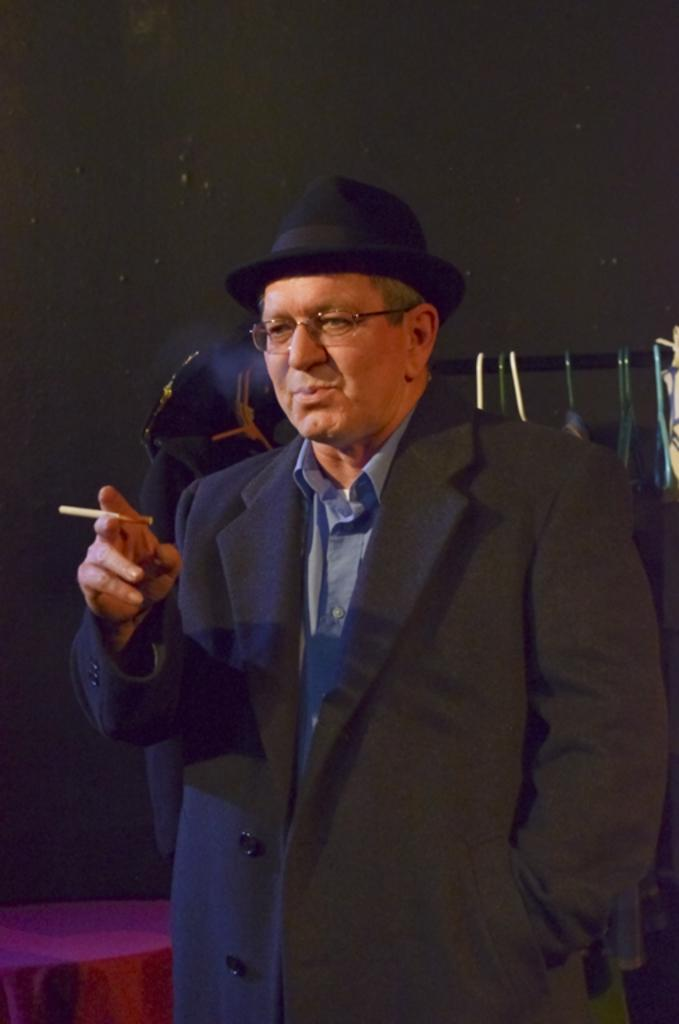Who is present in the image? There is a man in the image. What is the man wearing? The man is wearing a suit. What accessory is the man wearing on his face? The man has spectacles. What can be seen in the background of the image? There is a wall in the background of the image. What type of stitch is being used to repair the toys in the image? There are no toys present in the image, and therefore no stitching or repair work can be observed. 